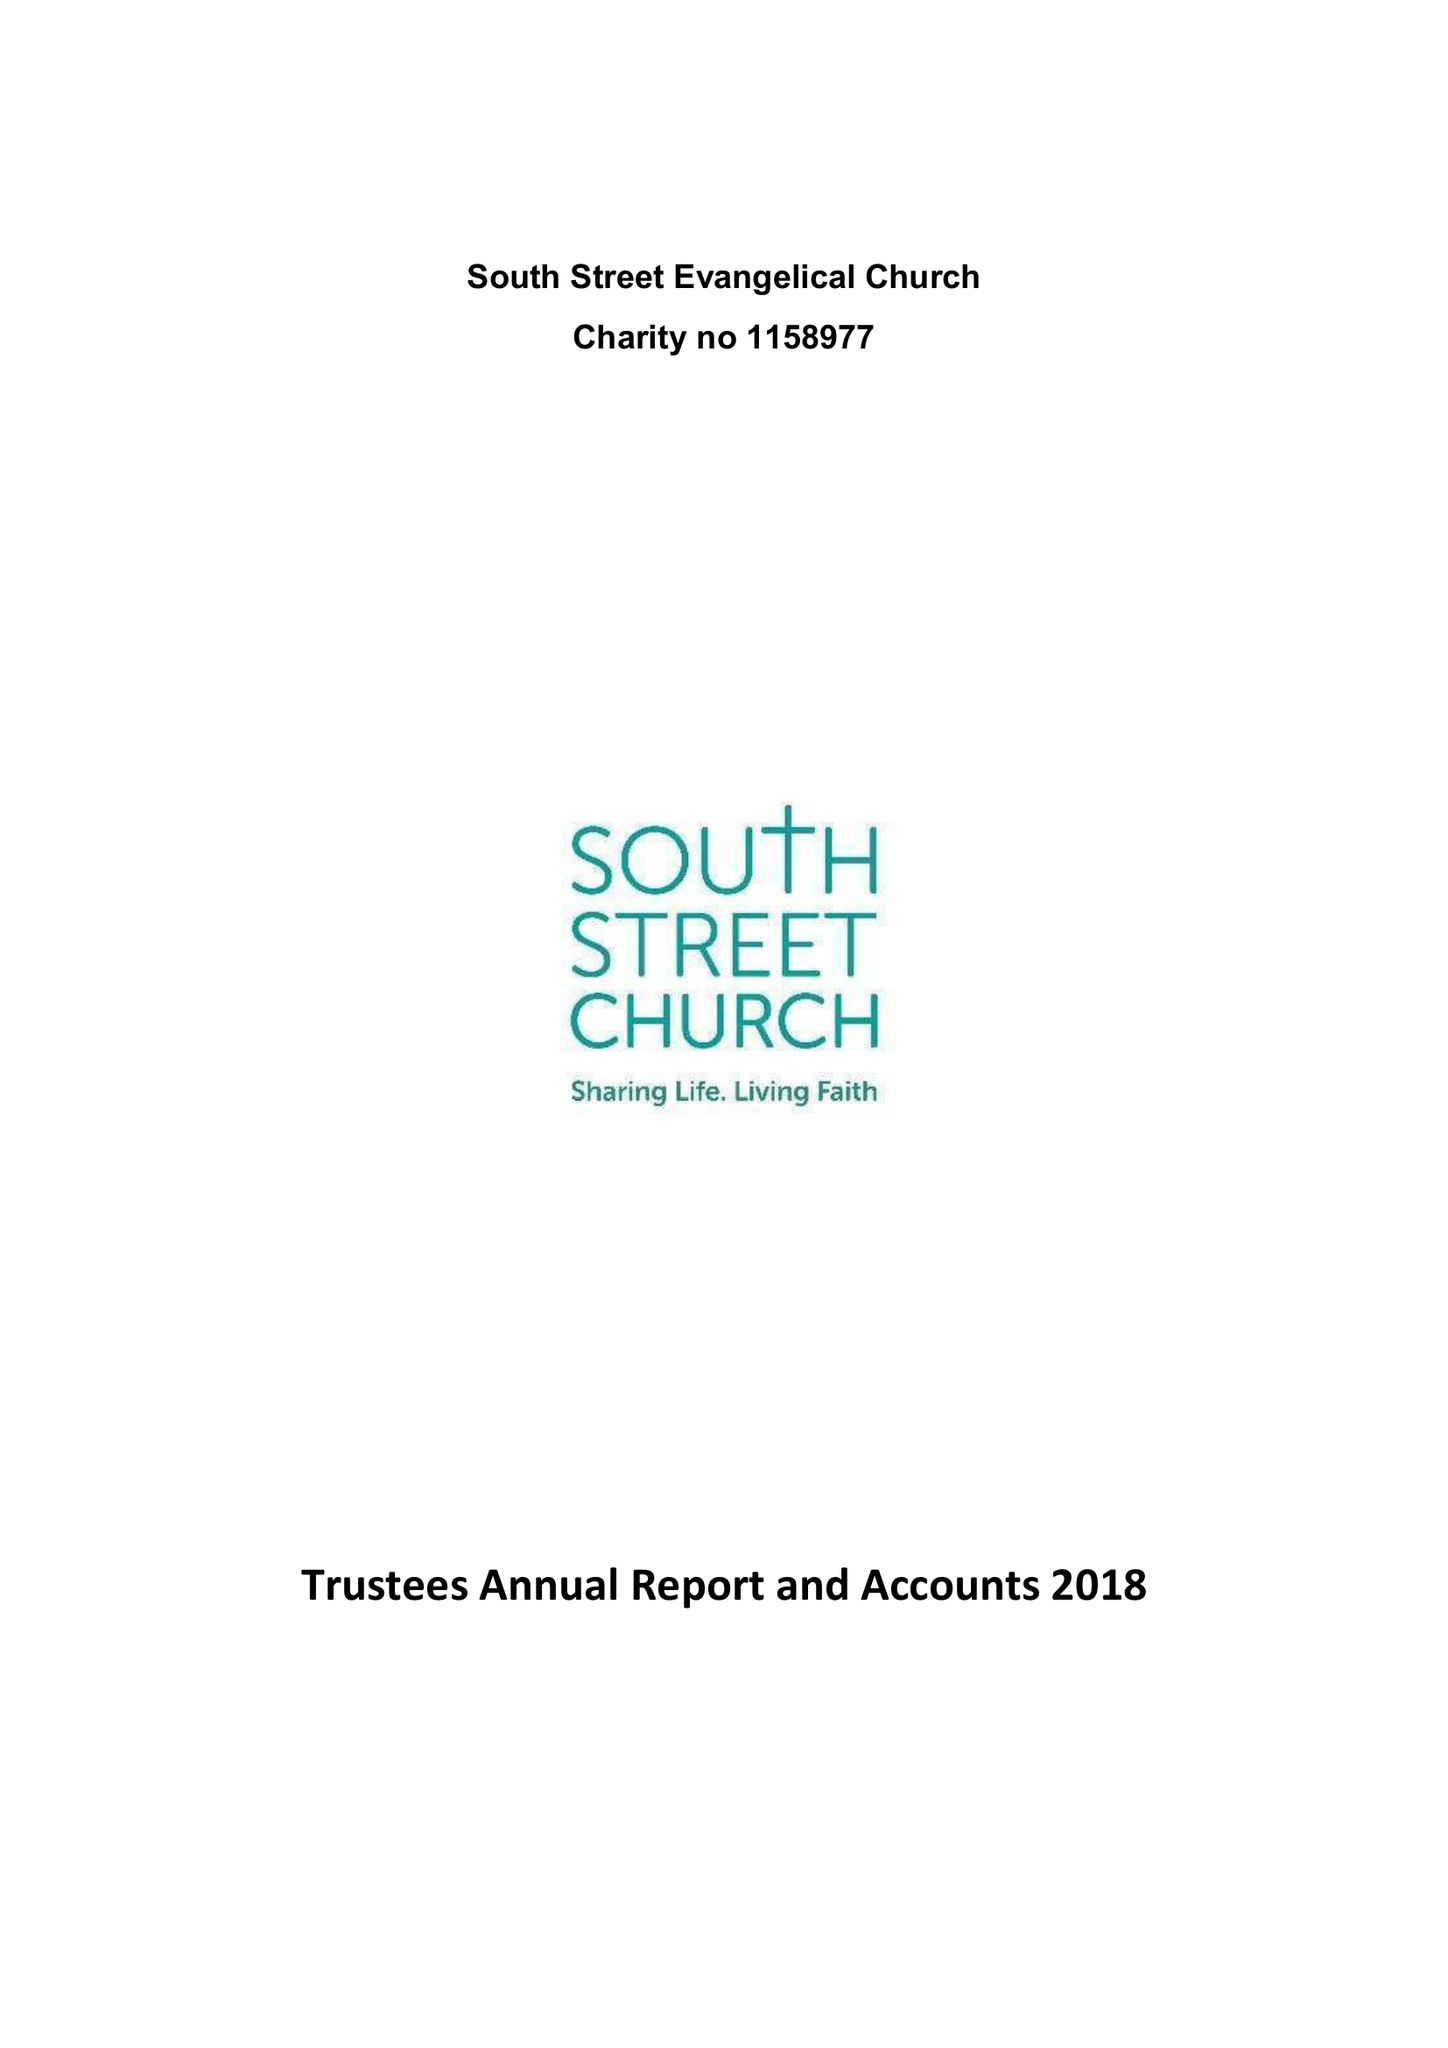What is the value for the address__post_town?
Answer the question using a single word or phrase. BRAUNTON 